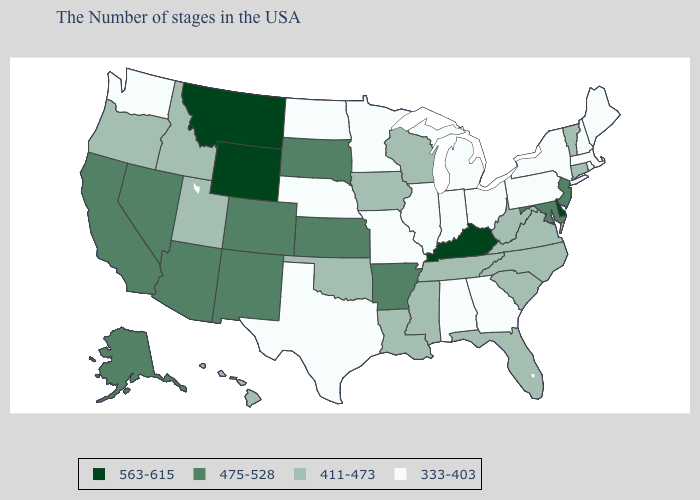Does the first symbol in the legend represent the smallest category?
Concise answer only. No. Name the states that have a value in the range 411-473?
Give a very brief answer. Vermont, Connecticut, Virginia, North Carolina, South Carolina, West Virginia, Florida, Tennessee, Wisconsin, Mississippi, Louisiana, Iowa, Oklahoma, Utah, Idaho, Oregon, Hawaii. Which states have the lowest value in the USA?
Give a very brief answer. Maine, Massachusetts, Rhode Island, New Hampshire, New York, Pennsylvania, Ohio, Georgia, Michigan, Indiana, Alabama, Illinois, Missouri, Minnesota, Nebraska, Texas, North Dakota, Washington. Does the map have missing data?
Write a very short answer. No. Does Kentucky have the same value as Florida?
Keep it brief. No. What is the highest value in the South ?
Answer briefly. 563-615. Name the states that have a value in the range 563-615?
Write a very short answer. Delaware, Kentucky, Wyoming, Montana. What is the lowest value in the USA?
Be succinct. 333-403. What is the value of New Hampshire?
Give a very brief answer. 333-403. Which states have the highest value in the USA?
Quick response, please. Delaware, Kentucky, Wyoming, Montana. Which states have the lowest value in the USA?
Give a very brief answer. Maine, Massachusetts, Rhode Island, New Hampshire, New York, Pennsylvania, Ohio, Georgia, Michigan, Indiana, Alabama, Illinois, Missouri, Minnesota, Nebraska, Texas, North Dakota, Washington. Name the states that have a value in the range 333-403?
Concise answer only. Maine, Massachusetts, Rhode Island, New Hampshire, New York, Pennsylvania, Ohio, Georgia, Michigan, Indiana, Alabama, Illinois, Missouri, Minnesota, Nebraska, Texas, North Dakota, Washington. Name the states that have a value in the range 411-473?
Concise answer only. Vermont, Connecticut, Virginia, North Carolina, South Carolina, West Virginia, Florida, Tennessee, Wisconsin, Mississippi, Louisiana, Iowa, Oklahoma, Utah, Idaho, Oregon, Hawaii. What is the highest value in the South ?
Keep it brief. 563-615. Does the first symbol in the legend represent the smallest category?
Be succinct. No. 